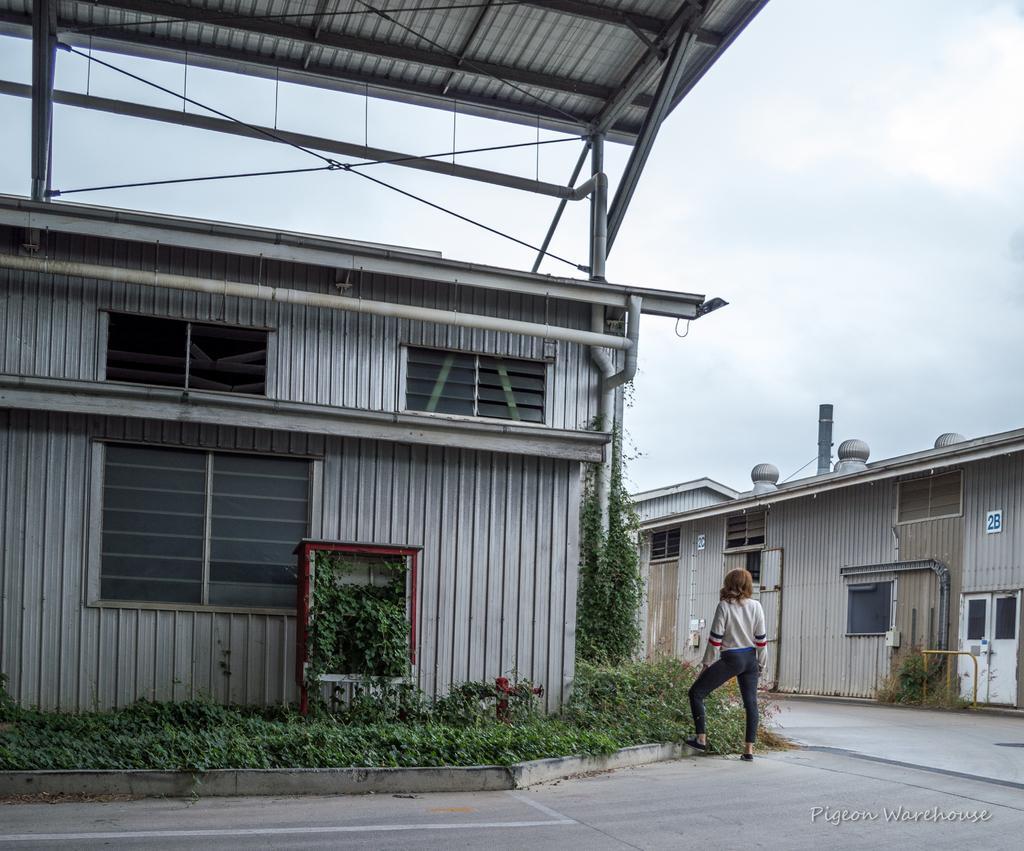Could you give a brief overview of what you see in this image? In this picture there is a white color small shed house in the front. On the right side we can see a girl wearing white color t-shirt is standing. On the right corner there is a shed house with window. 